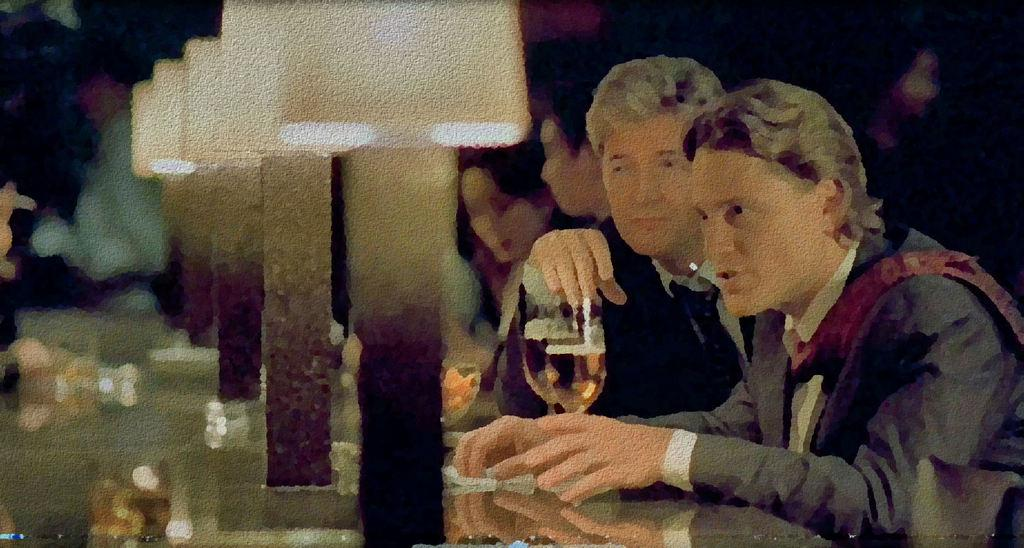What are the people in the image doing? The people in the image are sitting on the right side. What objects can be seen on the table in the image? There are lamps in series and glasses on the table. Is there a yard visible in the image? There is no yard visible in the image; it only shows people sitting and objects on a table. 